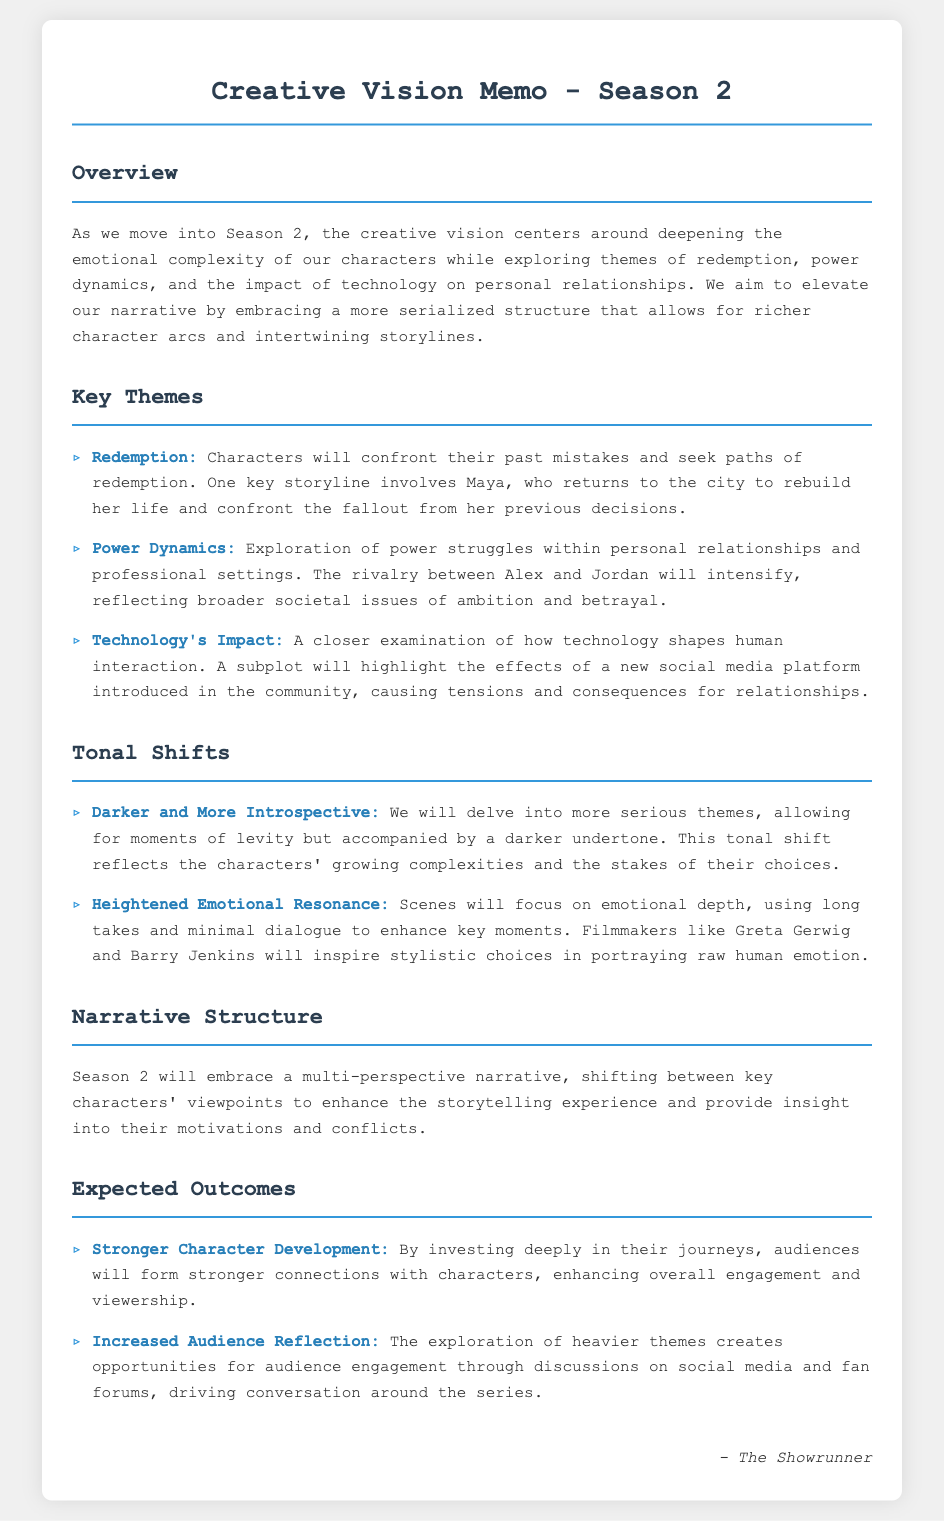What are the key themes of Season 2? The key themes of Season 2 include redemption, power dynamics, and technology's impact on personal relationships.
Answer: redemption, power dynamics, technology's impact Who is a key character seeking redemption? Maya is mentioned as a key character who will confront her past mistakes and seek paths of redemption.
Answer: Maya What tonal shift will Season 2 take? The tonal shift for Season 2 will be darker and more introspective, allowing for more serious themes.
Answer: darker and more introspective What narrative style is being embraced in Season 2? Season 2 will embrace a multi-perspective narrative, shifting between key characters' viewpoints.
Answer: multi-perspective narrative What expected outcome focuses on character development? Stronger character development is an expected outcome from investing deeply in character journeys.
Answer: Stronger character development What filmmaker inspirations are mentioned for emotional scenes? Filmmakers like Greta Gerwig and Barry Jenkins are mentioned as inspirations for emotional scenes.
Answer: Greta Gerwig, Barry Jenkins 